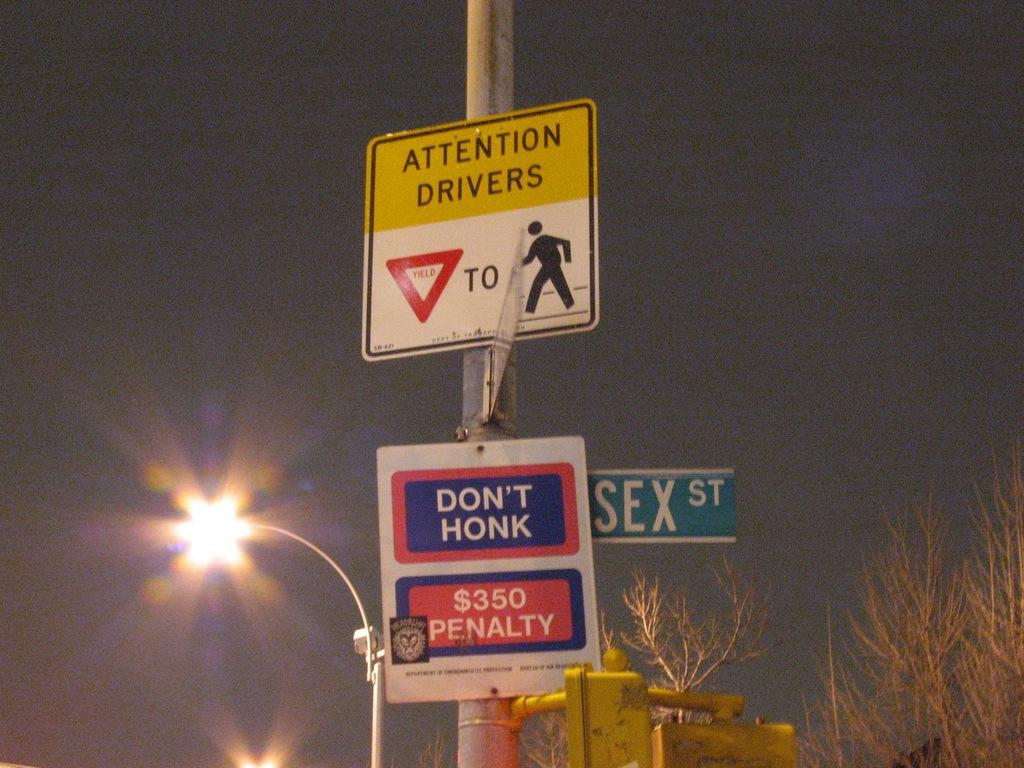<image>
Provide a brief description of the given image. Yellow and white sign which says Attention Drivers on a pole. 